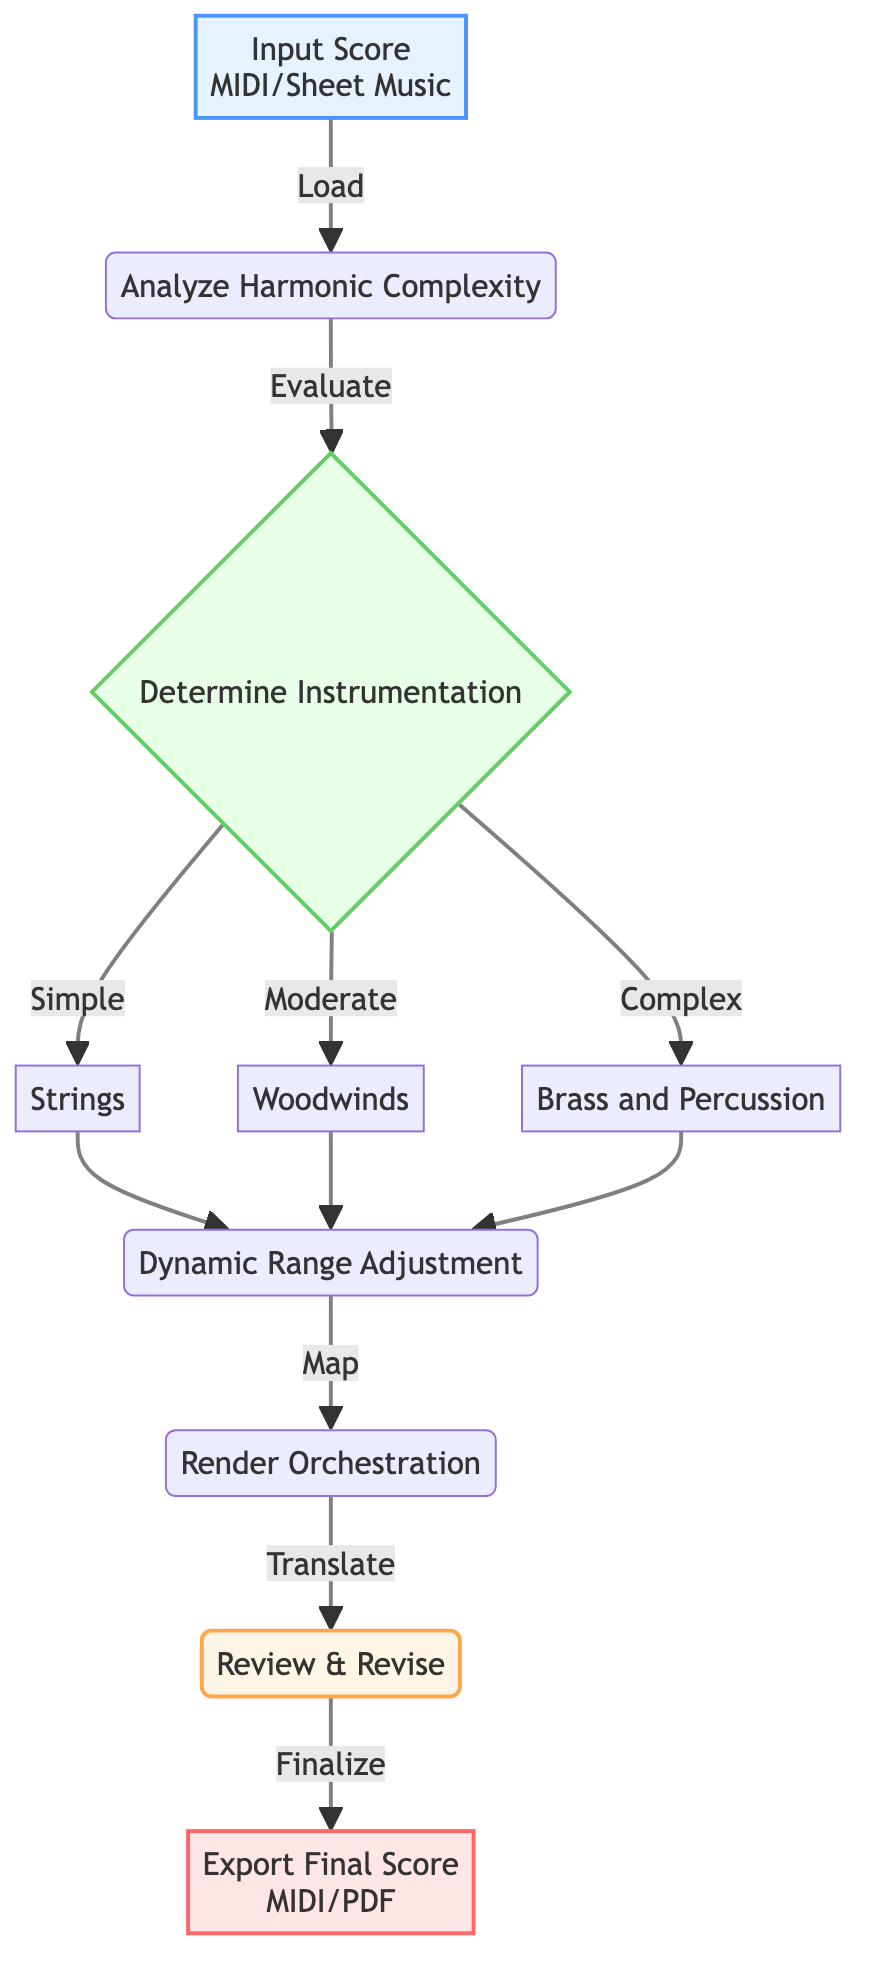What is the first step in the orchestration process? The first step is to load the musical score, which is performed in the node labeled "Input Score". This node represents the starting point for the orchestration workflow.
Answer: Load the musical score How many types of instrumentation are considered in the decision node? The decision node labeled "Determine Instrumentation" has three branches, which represent the types of instrumentation based on harmonic complexity: Simple, Moderate, and Complex.
Answer: Three What follows after analyzing harmonic complexity? After the node "Analyze Harmonic Complexity" evaluates the score, the flow directs to the decision node "Determine Instrumentation". This indicates that the evaluation leads directly to determining suitable instrumentation for the score.
Answer: Determine Instrumentation If the instrumentation is decided as "Brass and Percussion," which process follows? From the decision node "Determine Instrumentation", selecting "Complex" leads to the process node "Dynamic Range Adjustment". This shows that after determining the instrumentation as complex, the next step is to adjust the dynamic range.
Answer: Dynamic Range Adjustment What type of analysis is used to evaluate harmonic complexity? The process node "Analyze Harmonic Complexity" states that the evaluation is done through "Fourier Analysis/Harmonic Function Analysis," indicating the specific methods utilized for this purpose.
Answer: Fourier Analysis/Harmonic Function Analysis In total, how many process nodes are in the diagram? The diagram contains four distinct process nodes: "Analyze Harmonic Complexity", "Dynamic Range Adjustment", "Render Orchestration", and "Review & Revise". By counting each distinct process, we arrive at the total.
Answer: Four Which node is responsible for exporting the orchestration result? The final output node labeled "Export Final Score" is tasked with exporting the orchestrated score in the desired format, indicating this is where the final result is produced.
Answer: Export Final Score What is the purpose of the "Review & Revise" process? The process labeled "Review & Revise" involves manually reviewing the orchestration to ensure musicality. This shows that it acts as a checkpoint for quality and refinement before finalizing the output.
Answer: Ensure musicality Which tools are mentioned for the rendering process? The node "Render Orchestration" specifies the use of "Sibelius/Finale" as the software tools for translating the harmonic structure into orchestral parts, highlighting the technology used in this stage.
Answer: Sibelius/Finale 